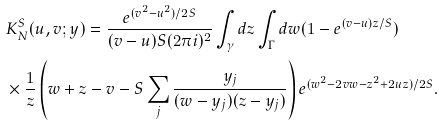Convert formula to latex. <formula><loc_0><loc_0><loc_500><loc_500>& K _ { N } ^ { S } ( u , v ; y ) = \frac { e ^ { ( v ^ { 2 } - u ^ { 2 } ) / 2 S } } { ( v - u ) S ( 2 \pi i ) ^ { 2 } } \int _ { \gamma } d z \int _ { \Gamma } d w ( 1 - e ^ { ( v - u ) z / S } ) \\ & \times \frac { 1 } { z } \left ( w + z - v - S \sum _ { j } \frac { y _ { j } } { ( w - y _ { j } ) ( z - y _ { j } ) } \right ) e ^ { ( w ^ { 2 } - 2 v w - z ^ { 2 } + 2 u z ) / 2 S } .</formula> 